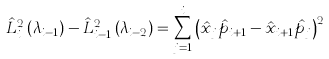Convert formula to latex. <formula><loc_0><loc_0><loc_500><loc_500>\hat { L } _ { i } ^ { 2 } \left ( \lambda _ { i - 1 } \right ) - \hat { L } _ { i - 1 } ^ { 2 } \left ( \lambda _ { i - 2 } \right ) = \sum _ { j = 1 } ^ { i } \left ( \hat { x } _ { j } \hat { p } _ { i + 1 } - \hat { x } _ { i + 1 } \hat { p } _ { j } \right ) ^ { 2 }</formula> 